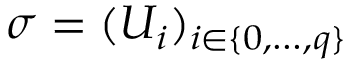Convert formula to latex. <formula><loc_0><loc_0><loc_500><loc_500>\sigma = ( U _ { i } ) _ { i \in \{ 0 , \dots , q \} }</formula> 